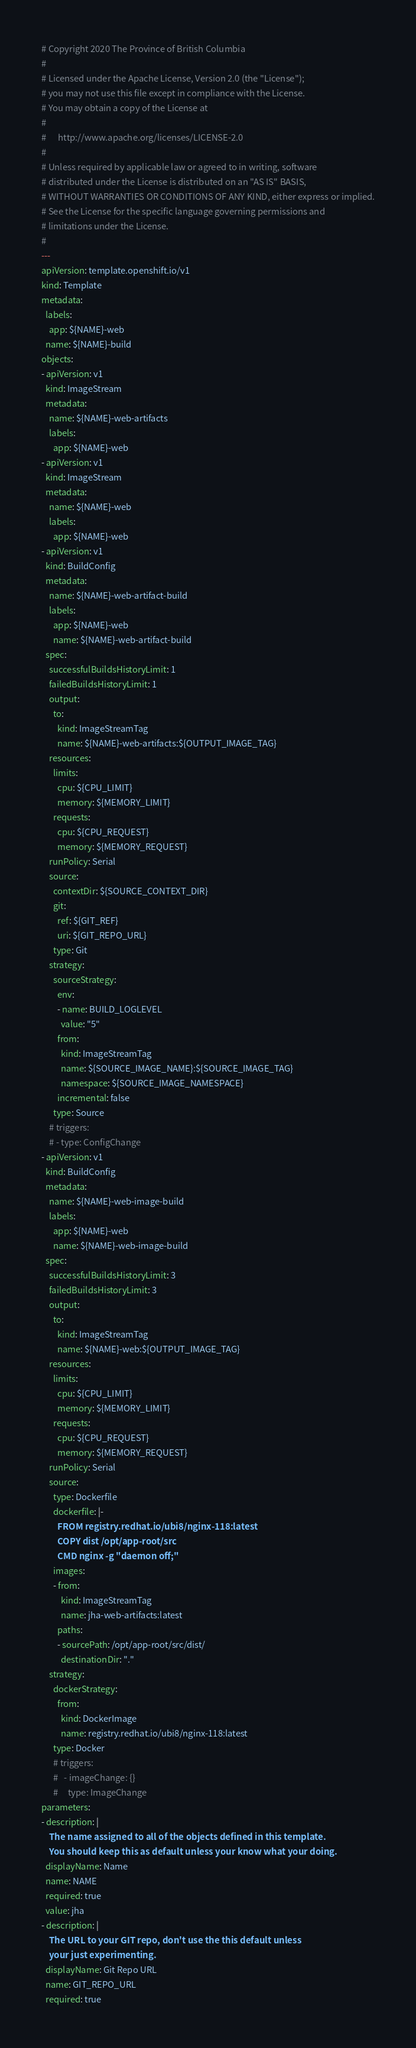<code> <loc_0><loc_0><loc_500><loc_500><_YAML_># Copyright 2020 The Province of British Columbia
#
# Licensed under the Apache License, Version 2.0 (the "License");
# you may not use this file except in compliance with the License.
# You may obtain a copy of the License at
#
#      http://www.apache.org/licenses/LICENSE-2.0
#
# Unless required by applicable law or agreed to in writing, software
# distributed under the License is distributed on an "AS IS" BASIS,
# WITHOUT WARRANTIES OR CONDITIONS OF ANY KIND, either express or implied.
# See the License for the specific language governing permissions and
# limitations under the License.
#
---
apiVersion: template.openshift.io/v1
kind: Template
metadata:
  labels:
    app: ${NAME}-web
  name: ${NAME}-build
objects:
- apiVersion: v1
  kind: ImageStream
  metadata:
    name: ${NAME}-web-artifacts
    labels:
      app: ${NAME}-web
- apiVersion: v1
  kind: ImageStream
  metadata:
    name: ${NAME}-web
    labels:
      app: ${NAME}-web
- apiVersion: v1
  kind: BuildConfig
  metadata:
    name: ${NAME}-web-artifact-build
    labels:
      app: ${NAME}-web
      name: ${NAME}-web-artifact-build
  spec:
    successfulBuildsHistoryLimit: 1
    failedBuildsHistoryLimit: 1
    output:
      to:
        kind: ImageStreamTag 
        name: ${NAME}-web-artifacts:${OUTPUT_IMAGE_TAG}
    resources:
      limits:
        cpu: ${CPU_LIMIT}
        memory: ${MEMORY_LIMIT}
      requests:
        cpu: ${CPU_REQUEST}
        memory: ${MEMORY_REQUEST}
    runPolicy: Serial
    source:
      contextDir: ${SOURCE_CONTEXT_DIR}
      git:
        ref: ${GIT_REF}
        uri: ${GIT_REPO_URL}
      type: Git
    strategy:
      sourceStrategy:
        env:
        - name: BUILD_LOGLEVEL
          value: "5"
        from:
          kind: ImageStreamTag
          name: ${SOURCE_IMAGE_NAME}:${SOURCE_IMAGE_TAG}
          namespace: ${SOURCE_IMAGE_NAMESPACE}
        incremental: false
      type: Source
    # triggers:
    # - type: ConfigChange
- apiVersion: v1
  kind: BuildConfig
  metadata:
    name: ${NAME}-web-image-build
    labels:
      app: ${NAME}-web
      name: ${NAME}-web-image-build
  spec:
    successfulBuildsHistoryLimit: 3
    failedBuildsHistoryLimit: 3
    output:
      to:
        kind: ImageStreamTag 
        name: ${NAME}-web:${OUTPUT_IMAGE_TAG}
    resources:
      limits:
        cpu: ${CPU_LIMIT}
        memory: ${MEMORY_LIMIT}
      requests:
        cpu: ${CPU_REQUEST}
        memory: ${MEMORY_REQUEST}
    runPolicy: Serial
    source:
      type: Dockerfile
      dockerfile: |-
        FROM registry.redhat.io/ubi8/nginx-118:latest
        COPY dist /opt/app-root/src
        CMD nginx -g "daemon off;"
      images:
      - from: 
          kind: ImageStreamTag
          name: jha-web-artifacts:latest
        paths: 
        - sourcePath: /opt/app-root/src/dist/
          destinationDir: "."
    strategy:
      dockerStrategy:
        from: 
          kind: DockerImage
          name: registry.redhat.io/ubi8/nginx-118:latest
      type: Docker
      # triggers:
      #   - imageChange: {}
      #     type: ImageChange
parameters:
- description: |
    The name assigned to all of the objects defined in this template.
    You should keep this as default unless your know what your doing.
  displayName: Name
  name: NAME
  required: true
  value: jha
- description: |
    The URL to your GIT repo, don't use the this default unless
    your just experimenting.
  displayName: Git Repo URL
  name: GIT_REPO_URL
  required: true</code> 